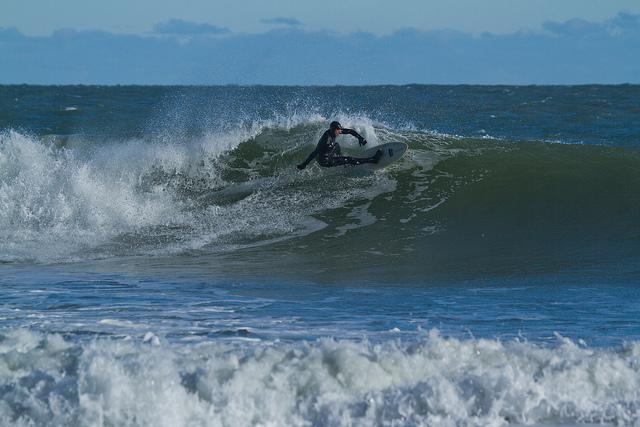Is the water cold?
Write a very short answer. Yes. Is this man surfing in the Arctic Ocean?
Short answer required. No. Is the surf rough?
Be succinct. Yes. What sport is this person engaging in?
Answer briefly. Surfing. Does the wave break over the boys head?
Concise answer only. No. Is the man wearing shorts?
Quick response, please. No. Is this person a novice?
Keep it brief. No. Which direction is the wave crashing?
Be succinct. Left. Is the person wearing a wetsuit?
Give a very brief answer. Yes. What type of boat is pulling the wakeboarder?
Quick response, please. None. 